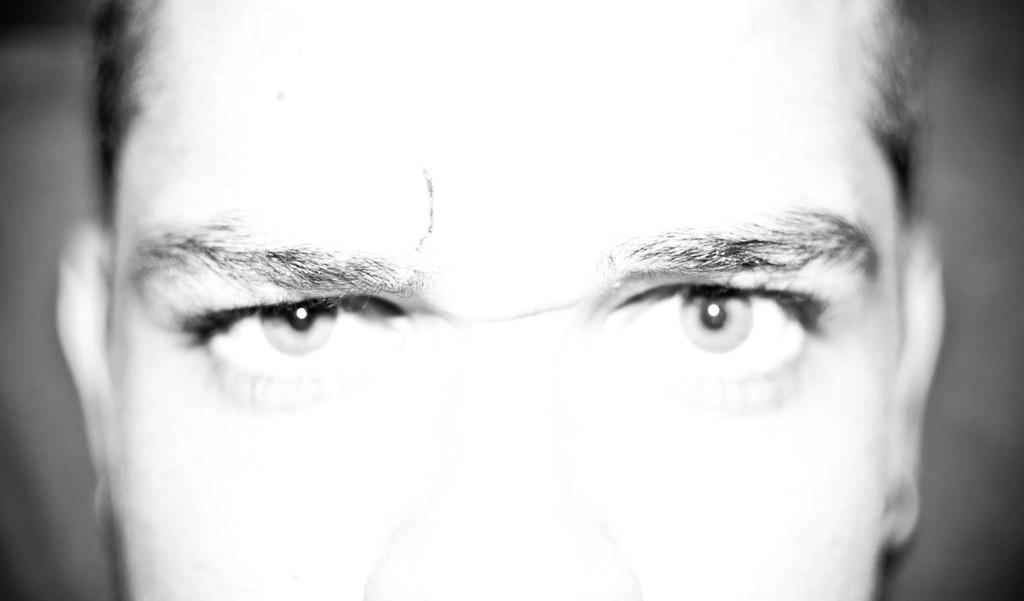What is the color scheme of the image? The image is black and white. What can be observed about the background of the image? The background of the image is blurred. What is the main subject of the image? There is a face of a man in the middle of the image. What type of quill is the man holding in the image? There is no quill present in the image; it is a black and white image of a man's face. What time does the alarm go off in the image? There is no alarm present in the image; it is a black and white image of a man's face. 